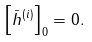<formula> <loc_0><loc_0><loc_500><loc_500>\left [ \bar { h } ^ { ( i ) } \right ] _ { 0 } = 0 .</formula> 